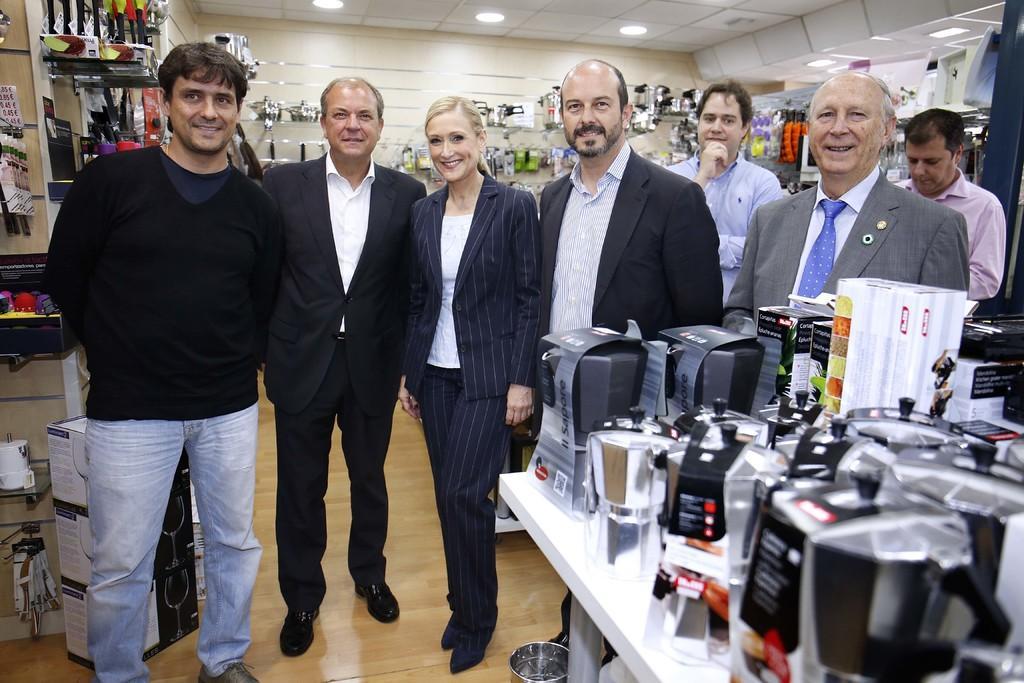Please provide a concise description of this image. In this image, we can see people standing and smiling. In the background, there are utensils. At the top, there are lights and at the bottom, there is floor. 